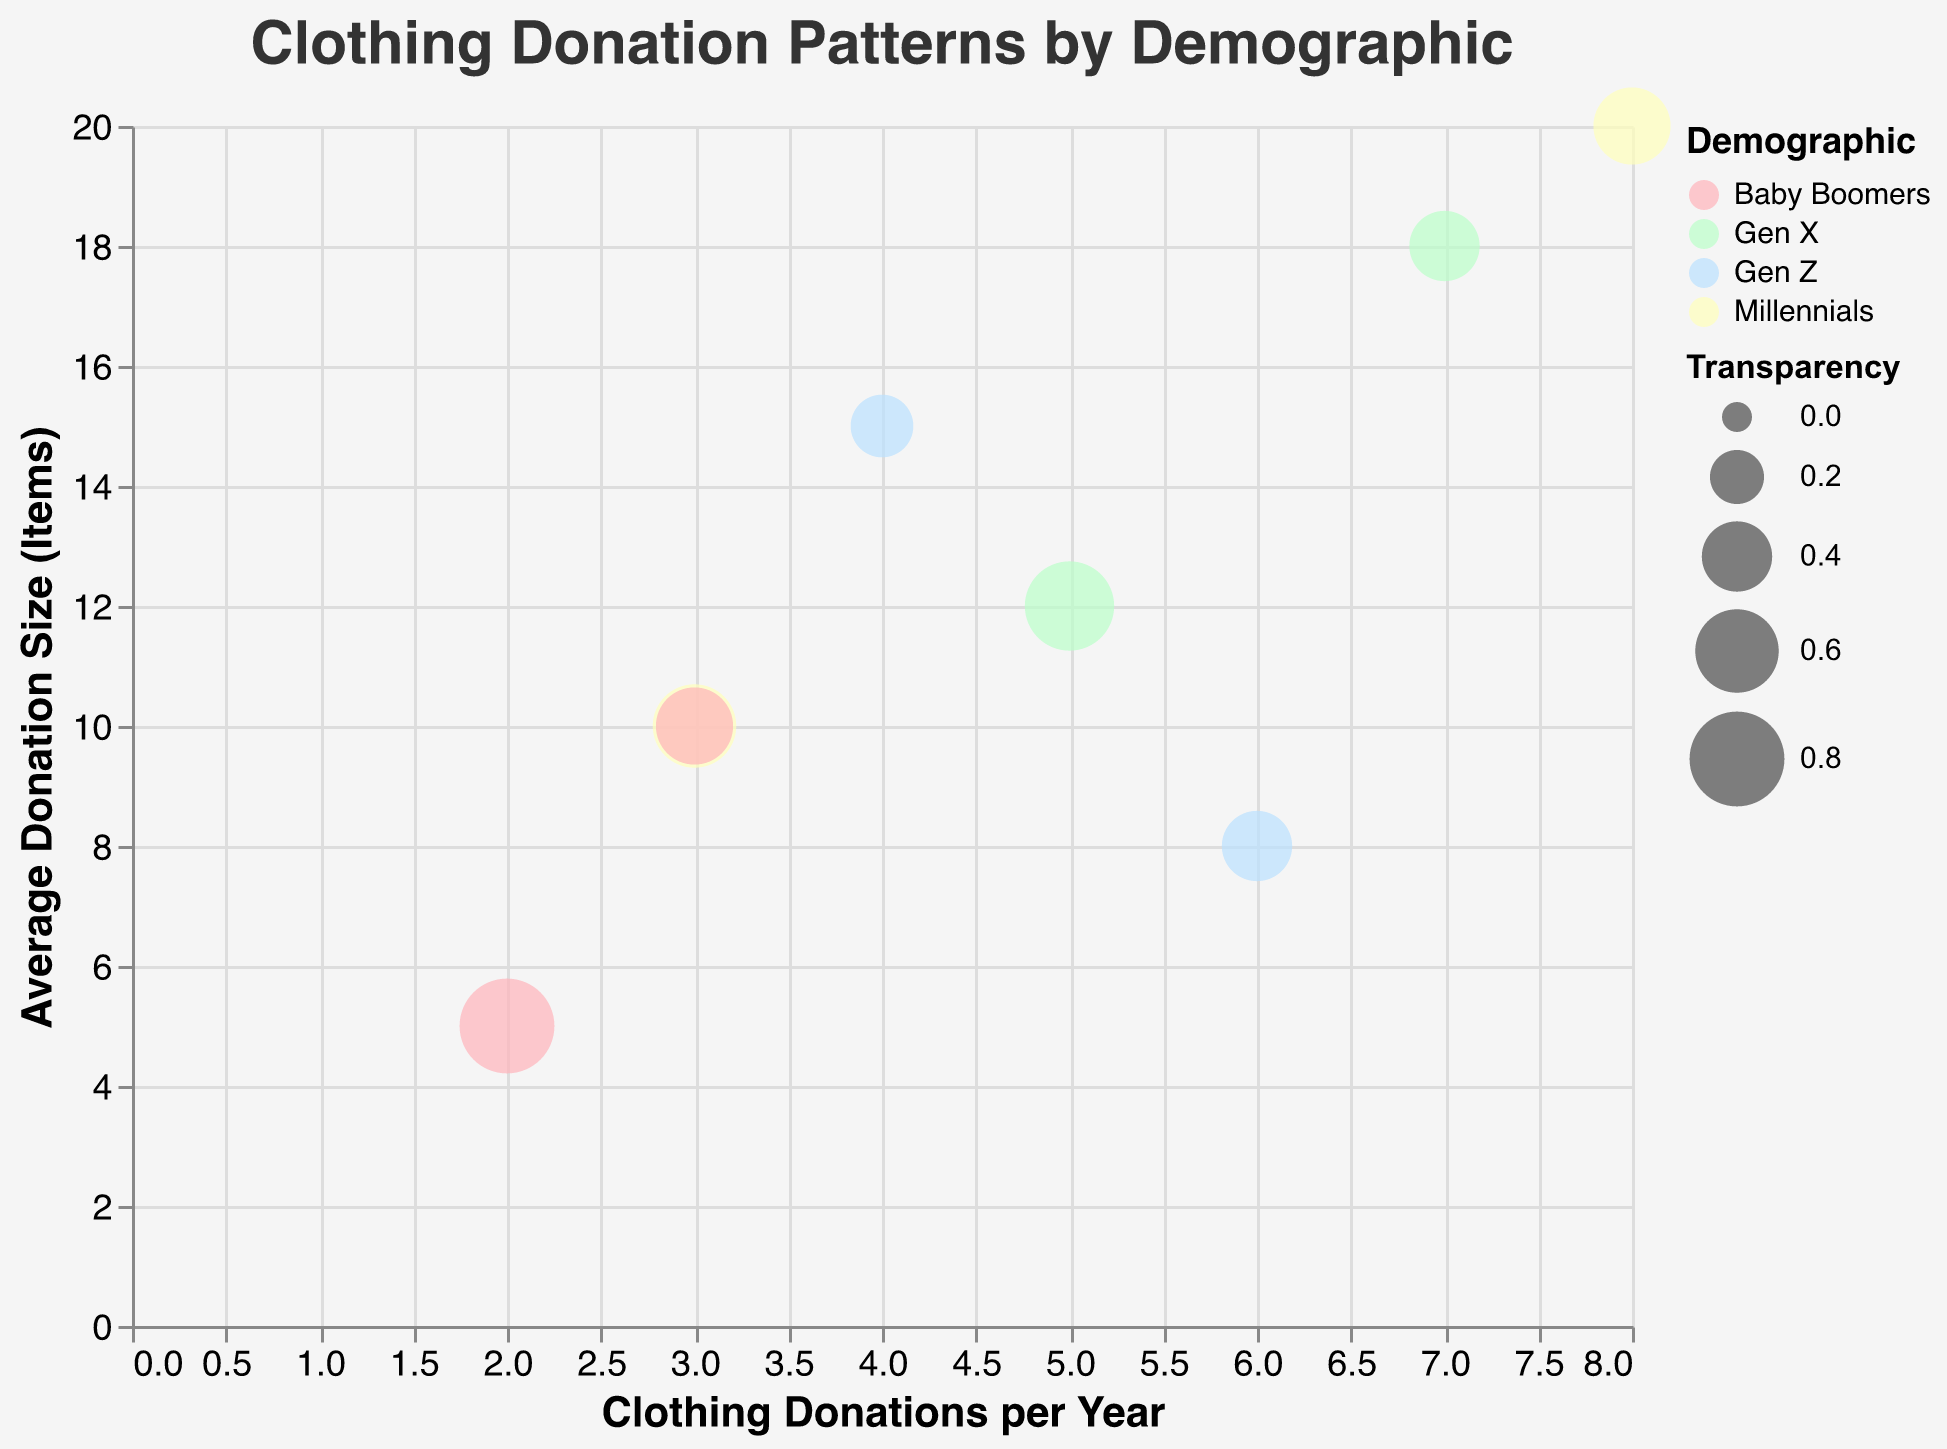How many demographic groups are represented in the chart? The legend shows the demographic categories. By counting them, we get Gen Z, Millennials, Gen X, and Baby Boomers.
Answer: 4 What is the title of the chart? The title is displayed prominently at the top of the chart.
Answer: Clothing Donation Patterns by Demographic Which demographic group donates the most often? Look for the highest value on the x-axis labeled "Clothing Donations per Year." The Millennials group shows the highest with 8 donations per year.
Answer: Millennials Which sustainable disposal method has the largest bubble on the chart? The size of the bubble corresponds to the transparency field. The largest bubble is from Gen X with "Recycle" apparent by the bubble size.
Answer: Recycle (Gen X) For the Gen Z demographic, which method results in a higher average donation size? Examine the two points for Gen Z: "Donate to Charity" with 15 items on the y-axis and "Recycle" with 8 items.
Answer: Donate to Charity What is the overall trend between donation frequency and average donation size for Millennials? Compare the two data points for Millennials: 8 donations and 20 items, and 3 donations and 10 items. As donation frequency increases, the average donation size also increases.
Answer: Positive correlation Which demographic has the most variety in sustainable disposal methods? Count the number of methods for each demographic group. Both Gen Z and Baby Boomers have 2 different methods each while Gen X and Millennials also have 2 methods each.
Answer: Tie (All) What is the smallest bubble's demographic and corresponding disposal method? The smallest bubble corresponds to the highest transparency value. Baby Boomers' "Upcycle" with transparency of 0.8 is the smallest.
Answer: Baby Boomers (Upcycle) How does the average donation size for Gen X's "Recycle" method compare to that of Baby Boomers' "Donate to Charity"? Gen X's "Recycle" method has an average of 12 items, while Baby Boomers' "Donate to Charity" has an average of 10 items. 12 is greater than 10.
Answer: Gen X (Recycle) What can you infer about the transparency and size of bubbles in relation to the number of clothing donations per year? The transparency varies with the demographic and disposal method, but typically higher donation frequencies don't consistently correlate with higher transparency values. This suggests other factors influence transparency.
Answer: No clear correlation 